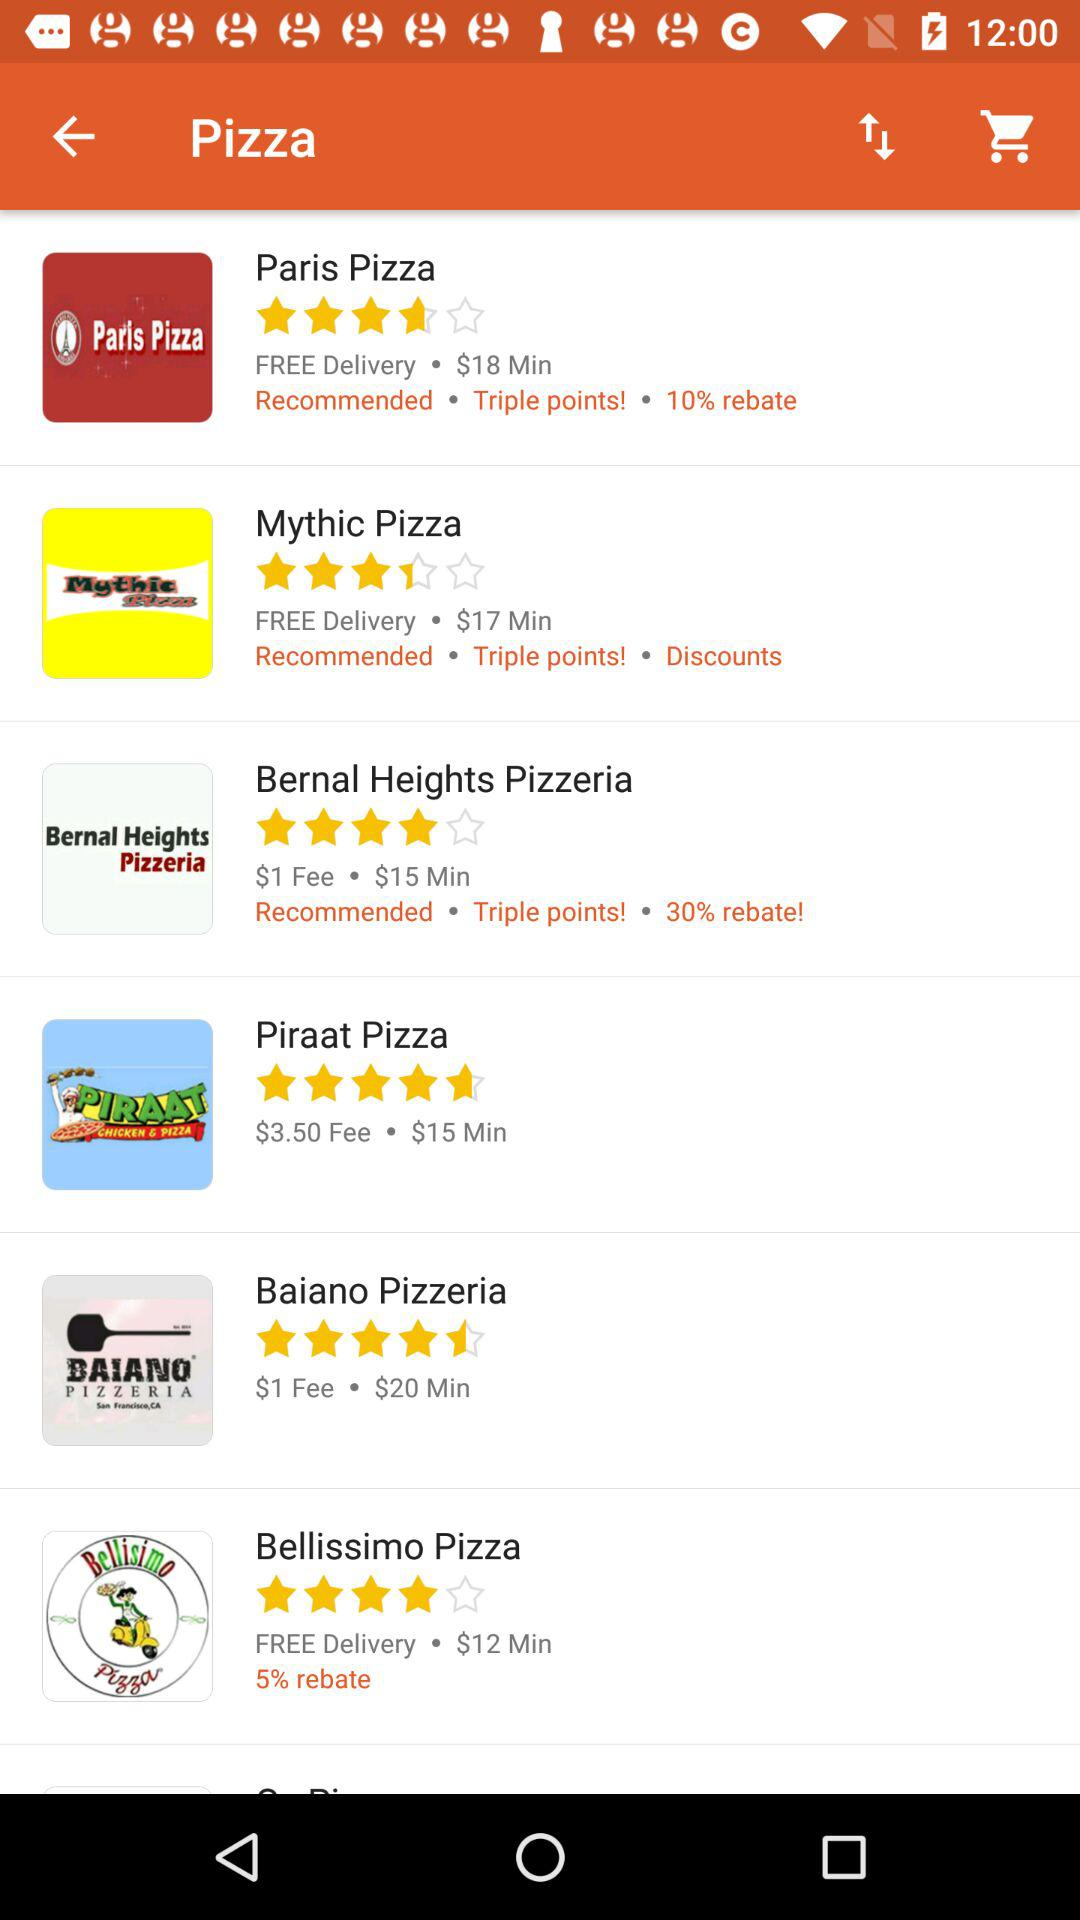What percentage of the rebate do we get at Bellissimo Pizza? You will get the 5% rebate at Bellissimo Pizza. 